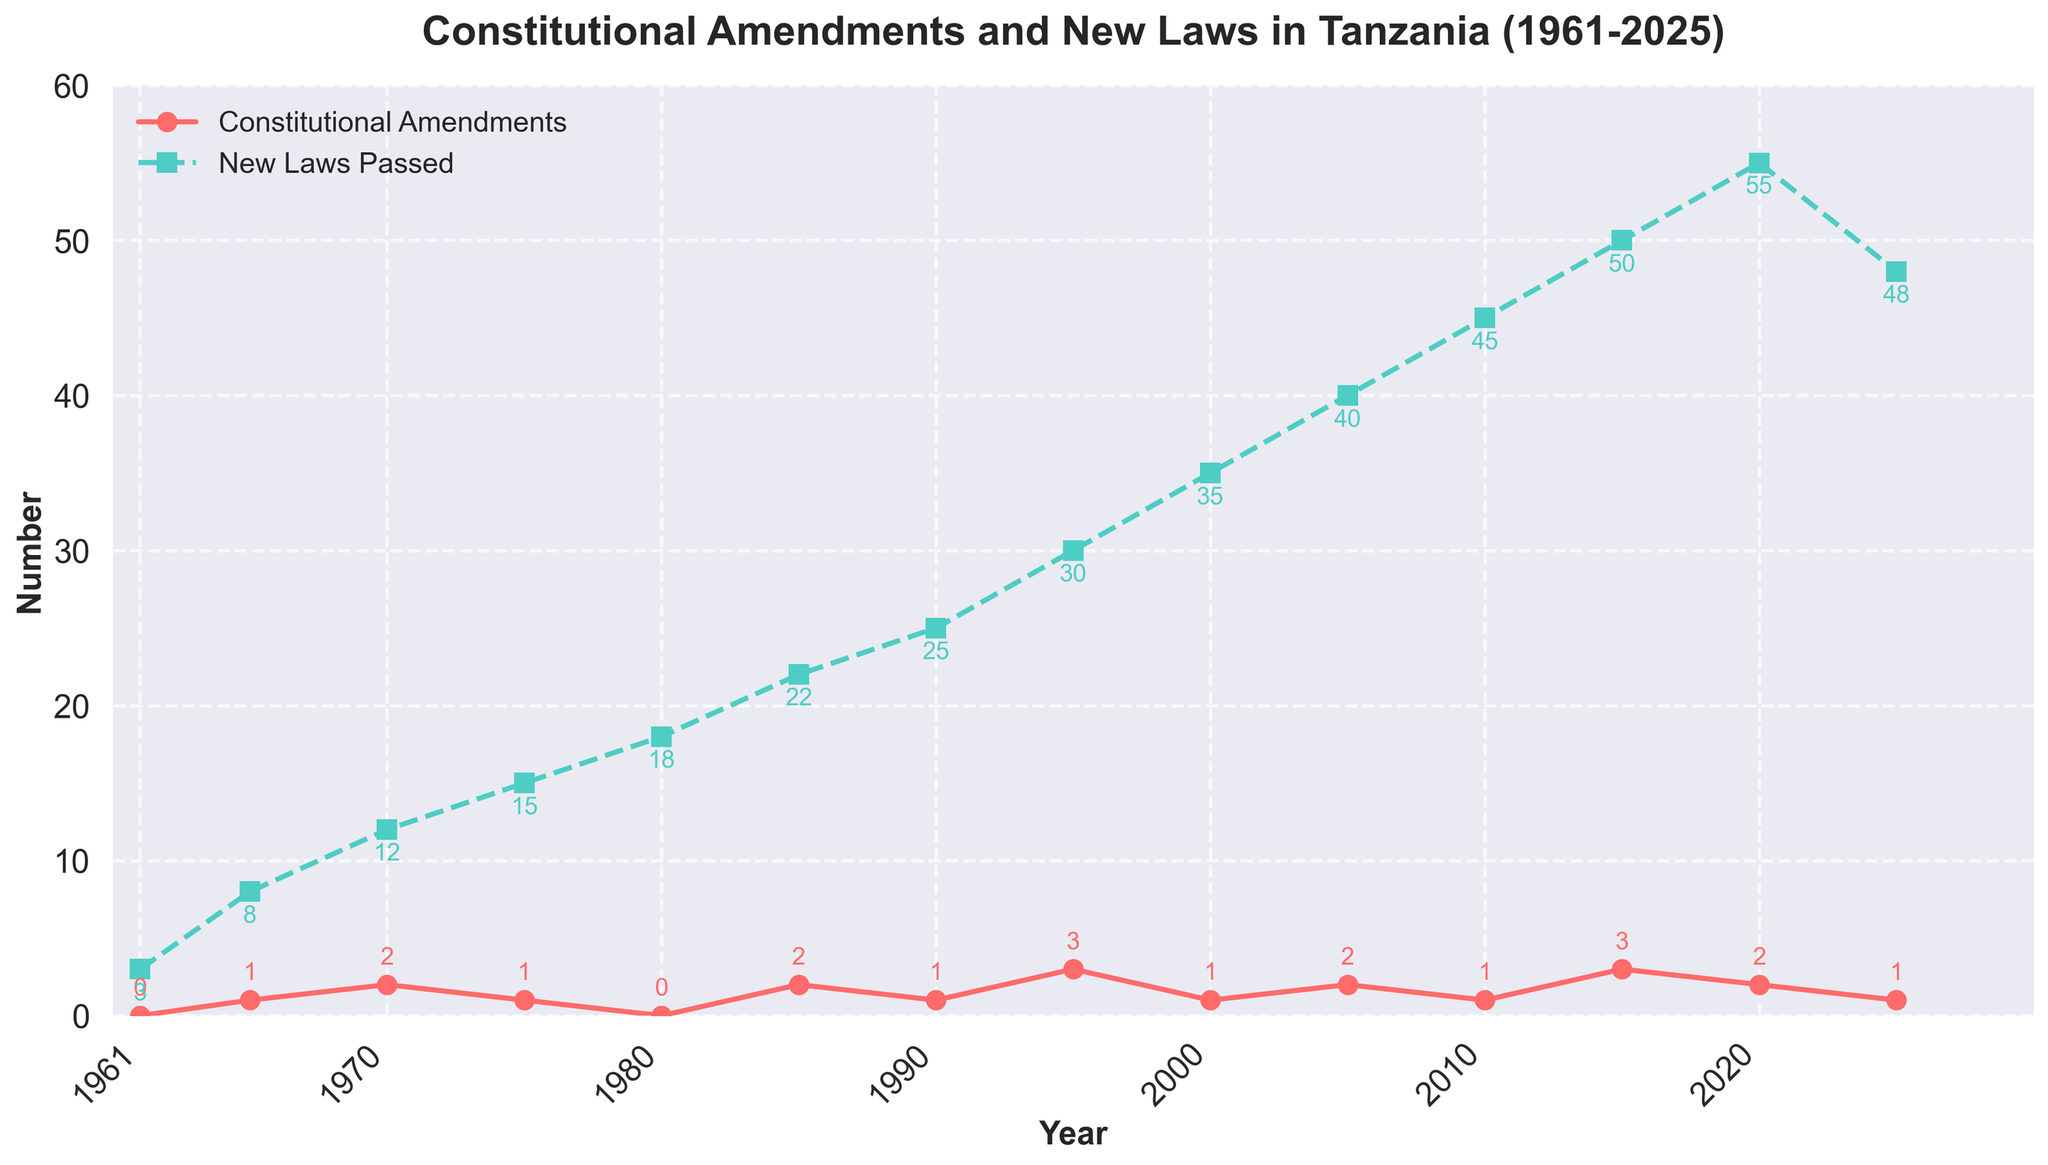What year had the highest number of new laws passed? First, observe the green line with squares representing new laws. Identify the year with the peak value, which is in 2020, with 55 new laws passed.
Answer: 2020 How many constitutional amendments were made in 1995? Look for the red line with circles representing constitutional amendments in 1995. The value at this point is 3.
Answer: 3 What is the sum of constitutional amendments for the years 1985, 1995, and 2015? Look at the red line for the years 1985 (2), 1995 (3), and 2015 (3). Sum these values: 2 + 3 + 3 = 8.
Answer: 8 In which year were an equal number of constitutional amendments and new laws passed? Examine both lines to find a year where the values align. In 1961, both are at 0 for constitutional amendments and 3 for new laws passed, so there is no year where their counts match.
Answer: None How did the number of new laws passed in 2000 compare with 1961? Compare the values: 2000 has 35 new laws, while 1961 has 3 new laws passed. Thus, 2000 had significantly more new laws.
Answer: 2000 had more What is the average number of new laws passed per year from 2010 to 2020? Identify the values for new laws passed in 2010 (45), 2015 (50), and 2020 (55). Calculate the average: (45 + 50 + 55) / 3 = 50.
Answer: 50 Which year showed a decrease in the number of new laws passed compared to the previous year? Look at the green line to identify any year where the value drops compared to the previous value. Notably, from 2020 (55) to 2025 (48), the number decreased.
Answer: 2025 What is the difference in the number of new laws passed between 1980 and 1985? Look at the values for new laws in these years: 18 in 1980 and 22 in 1985. Compute the difference: 22 - 18 = 4.
Answer: 4 Describe the overall trend in the number of constitutional amendments from 1961 to 2025. Observe the red line with circles. It shows fluctuations, notably peaking in certain years like 1995 and 2015, rather than a consistent upward or downward trend.
Answer: Fluctuating trend Which color represents constitutional amendments? Look at the color of the line representing constitutional amendments. It is red.
Answer: Red 